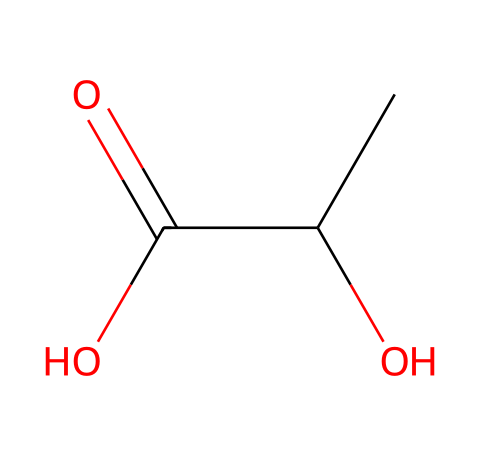What is the molecular formula of lactic acid? The molecular formula can be derived from the SMILES representation by counting the carbon (C), hydrogen (H), and oxygen (O) atoms. The structure reveals two carbons (C), four hydrogens (H), and three oxygens (O), leading to the formula C2H4O3.
Answer: C2H4O3 How many chiral centers are present in lactic acid? A chiral center is typically identified where a carbon atom is bonded to four different substituents. In lactic acid, one of the carbon atoms (the second carbon) has four different groups attached: a hydroxyl group, a methyl group, a carboxyl group, and a hydrogen atom, indicating one chiral center.
Answer: one What type of functional groups are present in lactic acid? By examining the structure, we identify both a hydroxyl group (-OH) and a carboxylic acid group (-COOH) in the molecule. These represent two distinct functional groups, essential in characterizing its chemical behavior.
Answer: hydroxyl and carboxylic acid What is the state of lactic acid at room temperature? The SMILES representation and knowledge of lactic acid’s properties indicate that at room temperature, it is typically a liquid due to its ability to form hydrogen bonds and its relatively low molecular weight.
Answer: liquid Is lactic acid optically active? A compound is optically active if it contains one or more chiral centers. Since lactic acid has one chiral center, it can exist in two enantiomeric forms that are non-superimposable mirror images of each other, making it optically active.
Answer: yes 